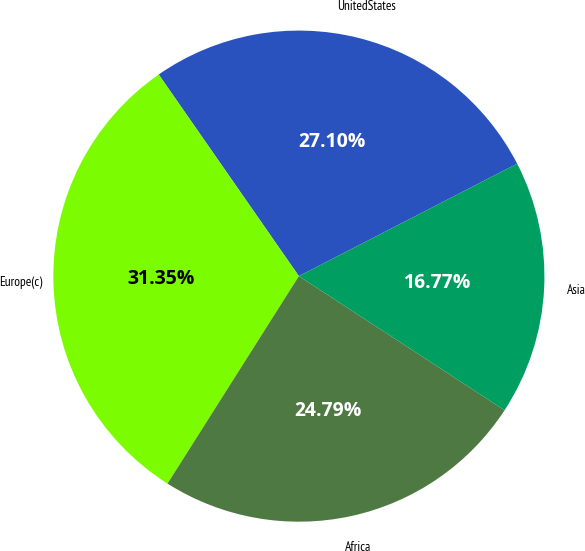<chart> <loc_0><loc_0><loc_500><loc_500><pie_chart><fcel>UnitedStates<fcel>Europe(c)<fcel>Africa<fcel>Asia<nl><fcel>27.1%<fcel>31.35%<fcel>24.79%<fcel>16.77%<nl></chart> 